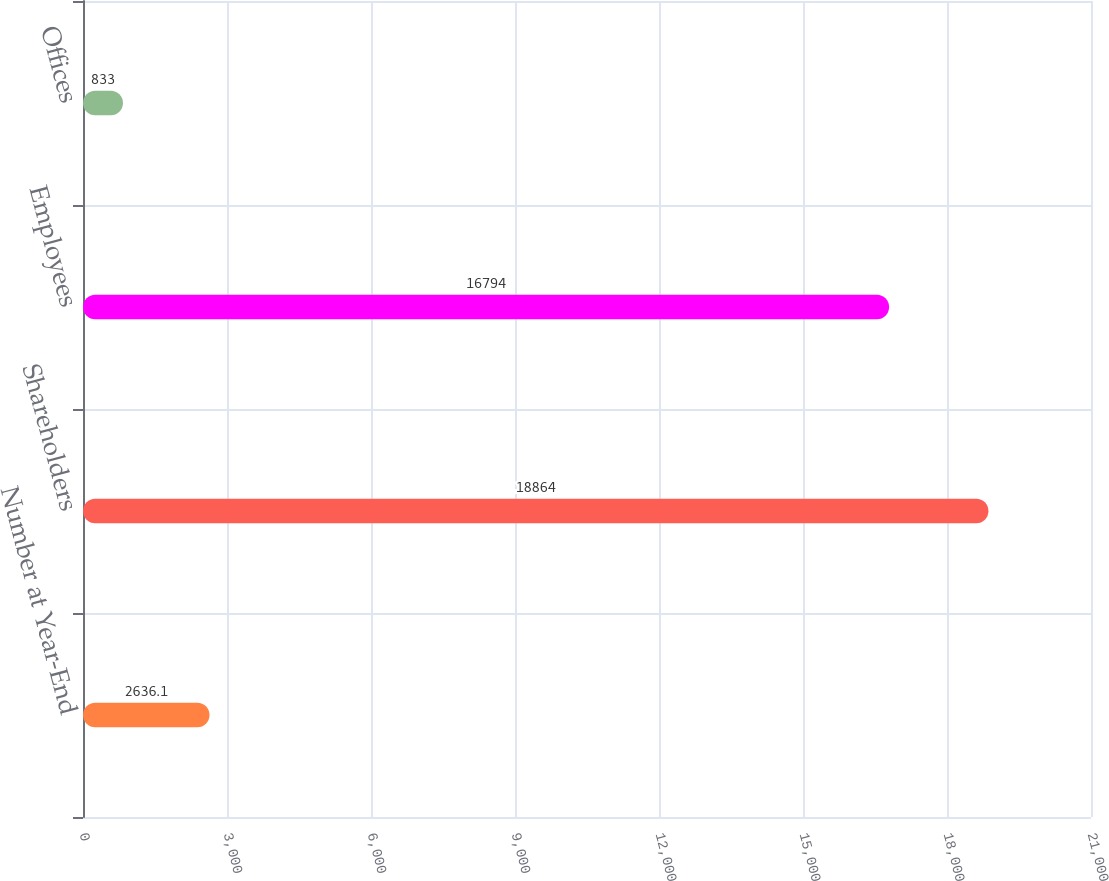Convert chart to OTSL. <chart><loc_0><loc_0><loc_500><loc_500><bar_chart><fcel>Number at Year-End<fcel>Shareholders<fcel>Employees<fcel>Offices<nl><fcel>2636.1<fcel>18864<fcel>16794<fcel>833<nl></chart> 